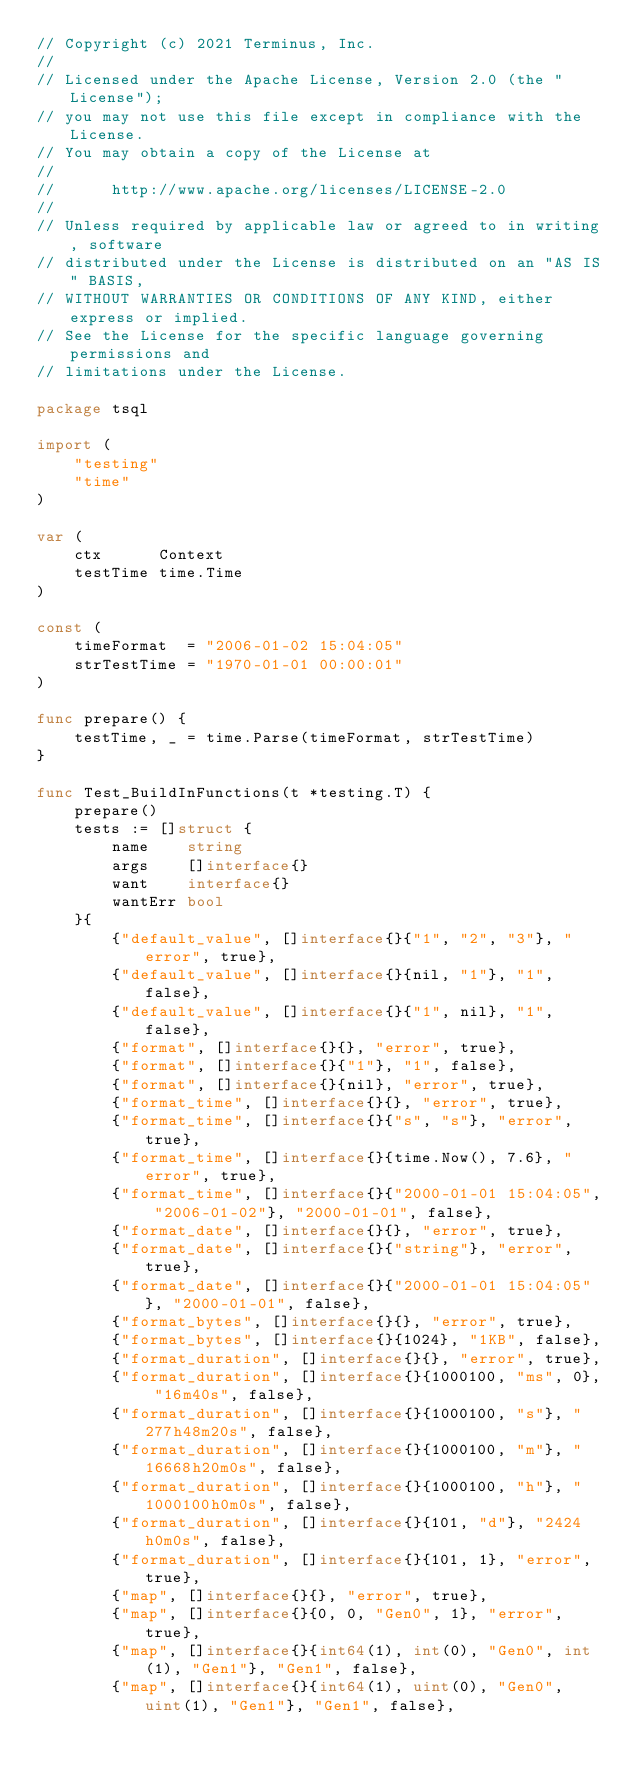Convert code to text. <code><loc_0><loc_0><loc_500><loc_500><_Go_>// Copyright (c) 2021 Terminus, Inc.
//
// Licensed under the Apache License, Version 2.0 (the "License");
// you may not use this file except in compliance with the License.
// You may obtain a copy of the License at
//
//      http://www.apache.org/licenses/LICENSE-2.0
//
// Unless required by applicable law or agreed to in writing, software
// distributed under the License is distributed on an "AS IS" BASIS,
// WITHOUT WARRANTIES OR CONDITIONS OF ANY KIND, either express or implied.
// See the License for the specific language governing permissions and
// limitations under the License.

package tsql

import (
	"testing"
	"time"
)

var (
	ctx      Context
	testTime time.Time
)

const (
	timeFormat  = "2006-01-02 15:04:05"
	strTestTime = "1970-01-01 00:00:01"
)

func prepare() {
	testTime, _ = time.Parse(timeFormat, strTestTime)
}

func Test_BuildInFunctions(t *testing.T) {
	prepare()
	tests := []struct {
		name    string
		args    []interface{}
		want    interface{}
		wantErr bool
	}{
		{"default_value", []interface{}{"1", "2", "3"}, "error", true},
		{"default_value", []interface{}{nil, "1"}, "1", false},
		{"default_value", []interface{}{"1", nil}, "1", false},
		{"format", []interface{}{}, "error", true},
		{"format", []interface{}{"1"}, "1", false},
		{"format", []interface{}{nil}, "error", true},
		{"format_time", []interface{}{}, "error", true},
		{"format_time", []interface{}{"s", "s"}, "error", true},
		{"format_time", []interface{}{time.Now(), 7.6}, "error", true},
		{"format_time", []interface{}{"2000-01-01 15:04:05", "2006-01-02"}, "2000-01-01", false},
		{"format_date", []interface{}{}, "error", true},
		{"format_date", []interface{}{"string"}, "error", true},
		{"format_date", []interface{}{"2000-01-01 15:04:05"}, "2000-01-01", false},
		{"format_bytes", []interface{}{}, "error", true},
		{"format_bytes", []interface{}{1024}, "1KB", false},
		{"format_duration", []interface{}{}, "error", true},
		{"format_duration", []interface{}{1000100, "ms", 0}, "16m40s", false},
		{"format_duration", []interface{}{1000100, "s"}, "277h48m20s", false},
		{"format_duration", []interface{}{1000100, "m"}, "16668h20m0s", false},
		{"format_duration", []interface{}{1000100, "h"}, "1000100h0m0s", false},
		{"format_duration", []interface{}{101, "d"}, "2424h0m0s", false},
		{"format_duration", []interface{}{101, 1}, "error", true},
		{"map", []interface{}{}, "error", true},
		{"map", []interface{}{0, 0, "Gen0", 1}, "error", true},
		{"map", []interface{}{int64(1), int(0), "Gen0", int(1), "Gen1"}, "Gen1", false},
		{"map", []interface{}{int64(1), uint(0), "Gen0", uint(1), "Gen1"}, "Gen1", false},</code> 